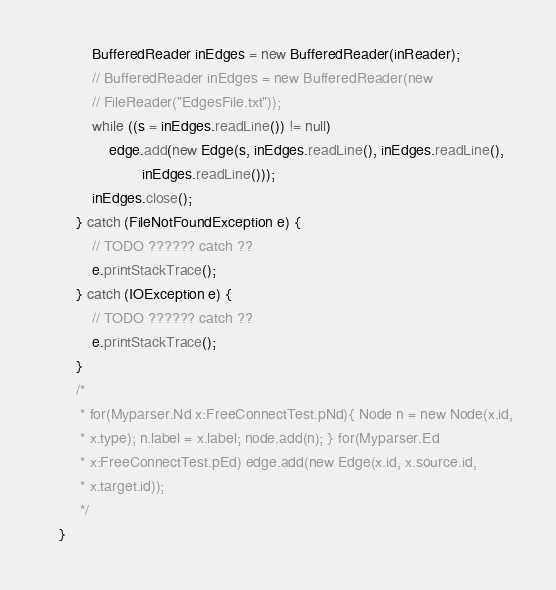<code> <loc_0><loc_0><loc_500><loc_500><_Java_>            BufferedReader inEdges = new BufferedReader(inReader);
            // BufferedReader inEdges = new BufferedReader(new
            // FileReader("EdgesFile.txt"));
            while ((s = inEdges.readLine()) != null)
                edge.add(new Edge(s, inEdges.readLine(), inEdges.readLine(),
                        inEdges.readLine()));
            inEdges.close();
        } catch (FileNotFoundException e) {
            // TODO ?????? catch ??
            e.printStackTrace();
        } catch (IOException e) {
            // TODO ?????? catch ??
            e.printStackTrace();
        }
        /*
         * for(Myparser.Nd x:FreeConnectTest.pNd){ Node n = new Node(x.id,
         * x.type); n.label = x.label; node.add(n); } for(Myparser.Ed
         * x:FreeConnectTest.pEd) edge.add(new Edge(x.id, x.source.id,
         * x.target.id));
         */
    }
</code> 